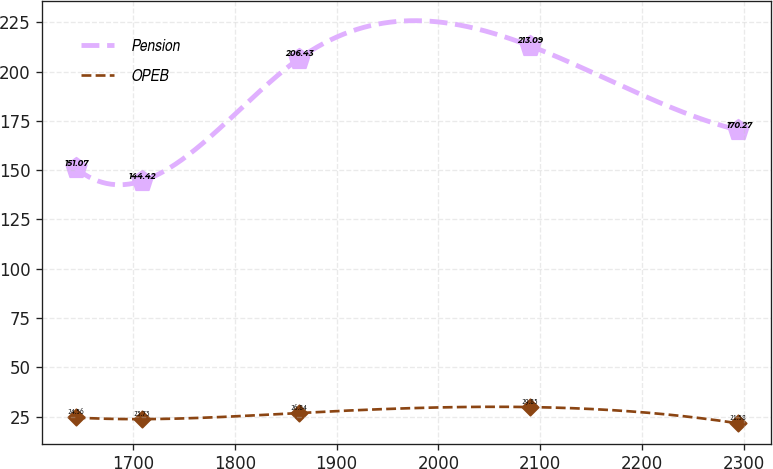<chart> <loc_0><loc_0><loc_500><loc_500><line_chart><ecel><fcel>Pension<fcel>OPEB<nl><fcel>1643.51<fcel>151.07<fcel>24.56<nl><fcel>1708.63<fcel>144.42<fcel>23.73<nl><fcel>1862.9<fcel>206.43<fcel>26.84<nl><fcel>2089.57<fcel>213.09<fcel>29.85<nl><fcel>2294.67<fcel>170.27<fcel>21.58<nl></chart> 